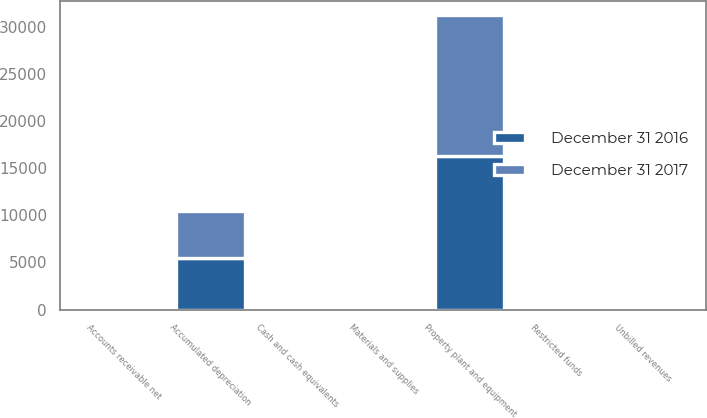Convert chart. <chart><loc_0><loc_0><loc_500><loc_500><stacked_bar_chart><ecel><fcel>Property plant and equipment<fcel>Accumulated depreciation<fcel>Cash and cash equivalents<fcel>Restricted funds<fcel>Accounts receivable net<fcel>Unbilled revenues<fcel>Materials and supplies<nl><fcel>December 31 2016<fcel>16246<fcel>5470<fcel>55<fcel>27<fcel>272<fcel>212<fcel>41<nl><fcel>December 31 2017<fcel>14992<fcel>4962<fcel>75<fcel>20<fcel>269<fcel>263<fcel>39<nl></chart> 